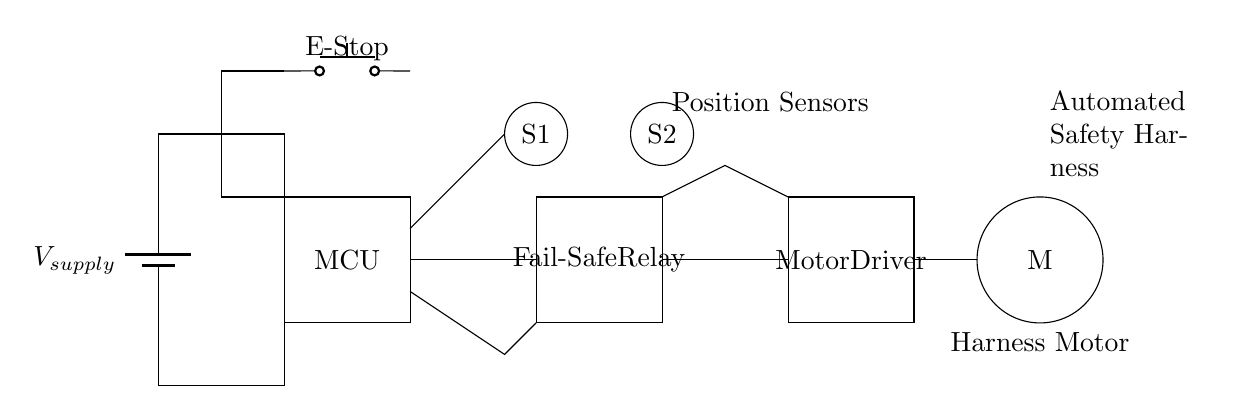What is the main function of the microcontroller? The microcontroller is responsible for processing inputs from the sensors and controlling the motor driver based on the acquired data to manage the safety harness mechanism.
Answer: Control What do the sensors represent in the circuit? The sensors, S1 and S2, are assumed to be position sensors that detect the position of the harness and provide feedback to the microcontroller.
Answer: Position What does the emergency stop button do? The emergency stop button is designed to immediately cut power to the system when activated, ensuring safety in case of an emergency.
Answer: Cut power How does the fail-safe relay contribute to safety? The fail-safe relay acts as a backup mechanism to ensure that the safety harness remains secure if the primary control system (the microcontroller) fails or receives a signal indicating an unsafe condition.
Answer: Backup mechanism What is the purpose of the motor in this circuit? The motor is responsible for adjusting the tension of the safety harness, ensuring it fits securely on the performer during aerial acrobatics.
Answer: Tension adjustment How many sensors are shown in the circuit? There are two sensors depicted in the circuit diagram, labeled S1 and S2.
Answer: Two 